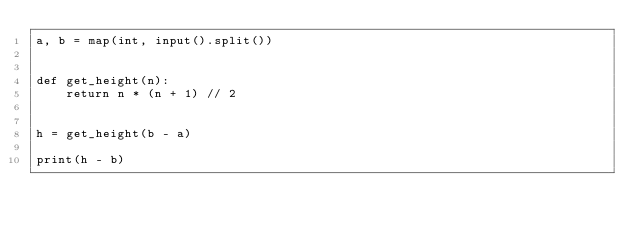Convert code to text. <code><loc_0><loc_0><loc_500><loc_500><_Python_>a, b = map(int, input().split())


def get_height(n):
    return n * (n + 1) // 2


h = get_height(b - a)

print(h - b)


</code> 